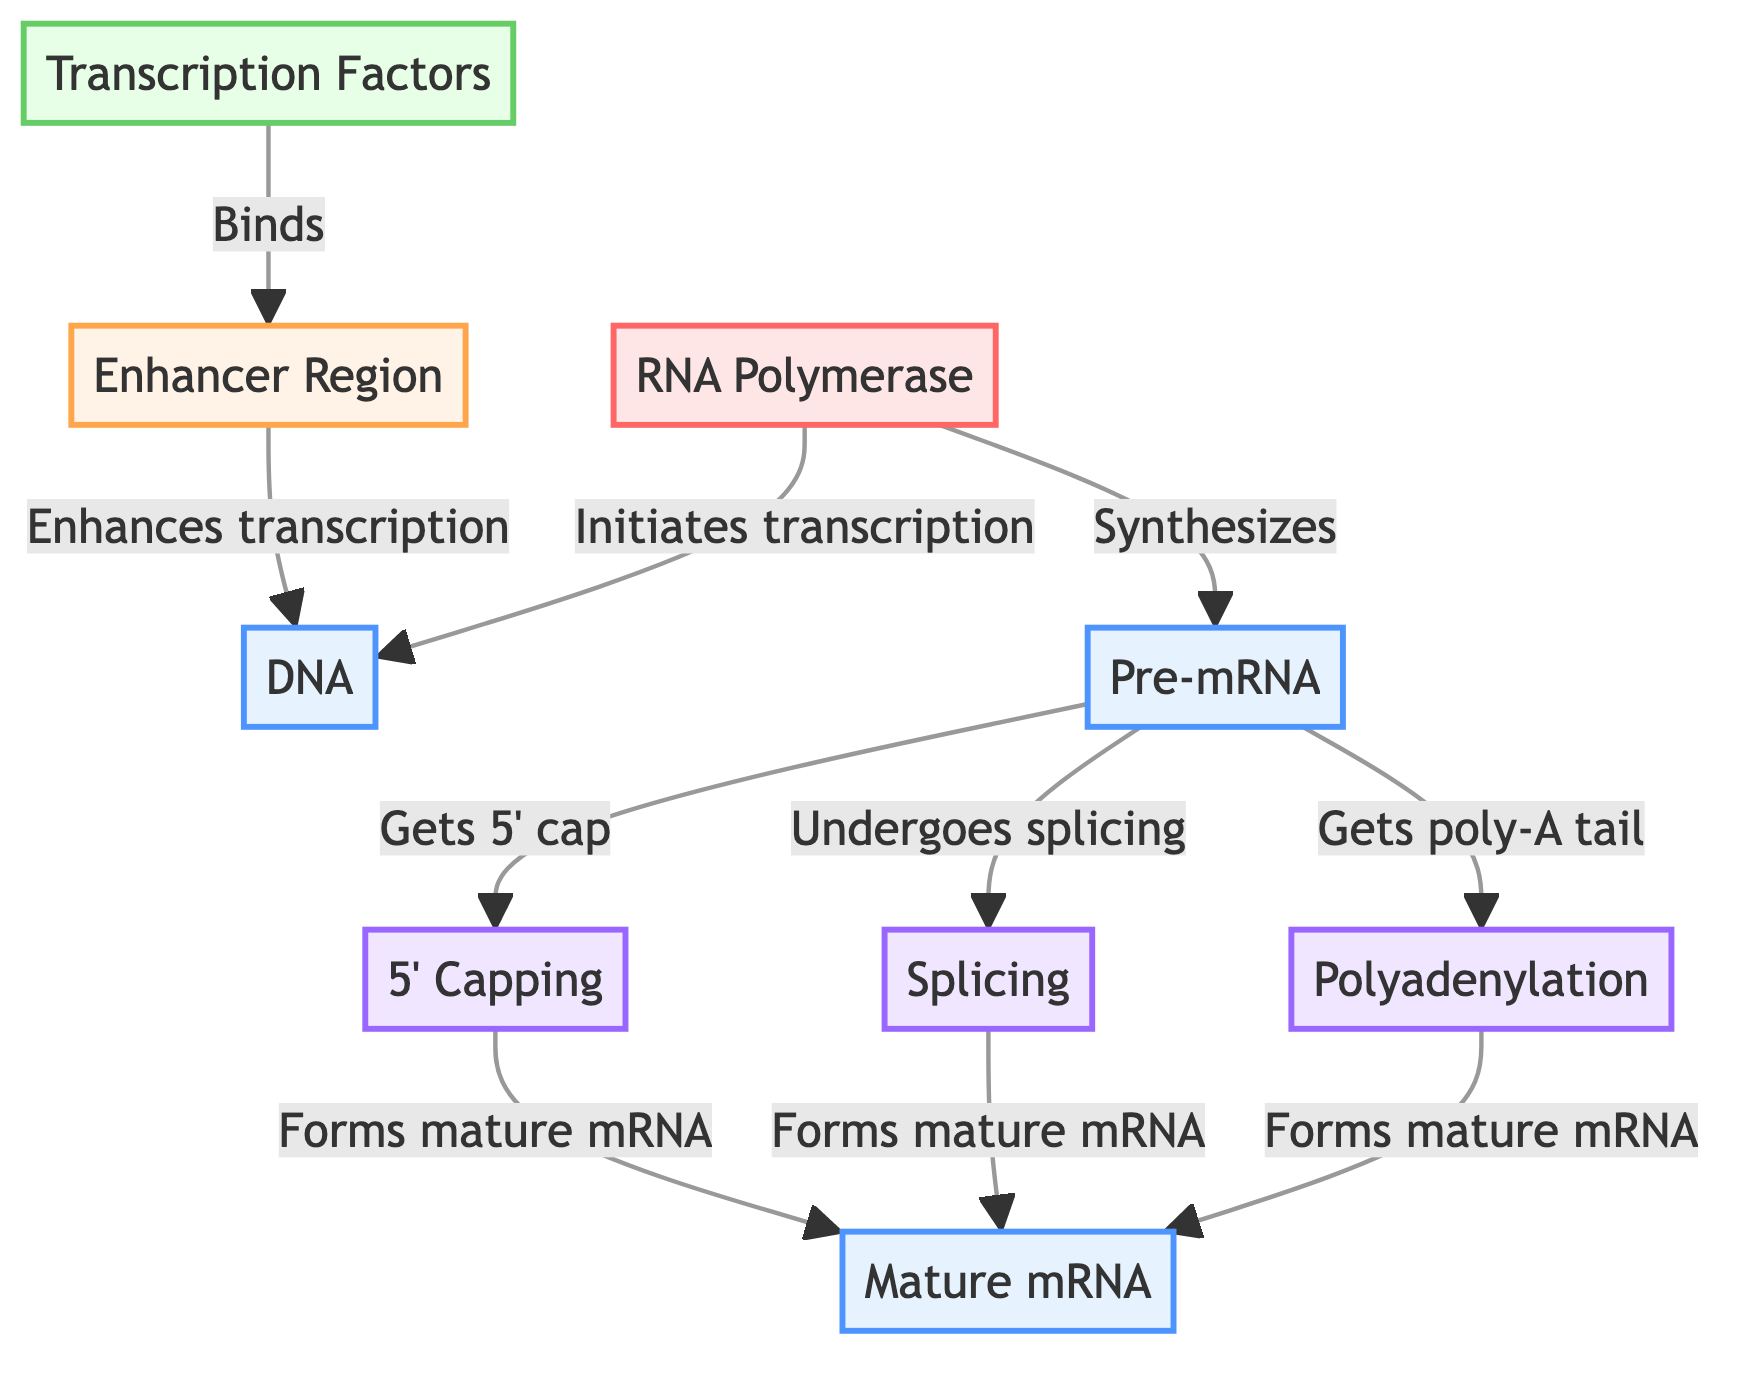What is the starting molecule in the pathway? The starting molecule is represented by the node labeled "DNA." This node is the first one in the flowchart and is essential for the transcription process.
Answer: DNA How many post-transcriptional modifications are shown in the diagram? There are three post-transcriptional modifications indicated in the diagram: 5' Capping, Splicing, and Polyadenylation. These are depicted as separate nodes connected to the Pre-mRNA node.
Answer: 3 What relays information from transcription factors to enhancer regions? According to the diagram, transcription factors bind to enhancer regions, indicated by the labeled arrow connecting the "Transcription Factors" node to the "Enhancer Region" node.
Answer: Binds Which molecule undergoes splicing? The node labeled "Pre-mRNA" undergoes splicing, as shown by the arrow that connects "Pre-mRNA" to the "Splicing" node, demonstrating the process it undergoes after transcription.
Answer: Pre-mRNA What is the final product of the modifications after splicing, capping, and polyadenylation? The final product is "Mature mRNA." This is indicated in the diagram where all three post-transcriptional modifications converge to form this end product.
Answer: Mature mRNA What molecule initiates transcription? The diagram shows that "RNA Polymerase" is the molecule that initiates transcription, as indicated by the arrow pointing from "RNA Polymerase" to the "DNA" node.
Answer: RNA Polymerase What type of process is indicated by the arrow from enhancer regions to DNA? The arrow from "Enhancer Region" to "DNA" is labeled "Enhances transcription," indicating that this is a regulatory process which increases the likelihood of transcription being initiated.
Answer: Enhances transcription 